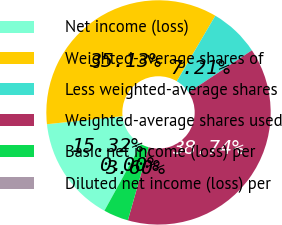<chart> <loc_0><loc_0><loc_500><loc_500><pie_chart><fcel>Net income (loss)<fcel>Weighted-average shares of<fcel>Less weighted-average shares<fcel>Weighted-average shares used<fcel>Basic net income (loss) per<fcel>Diluted net income (loss) per<nl><fcel>15.32%<fcel>35.13%<fcel>7.21%<fcel>38.74%<fcel>3.6%<fcel>0.0%<nl></chart> 